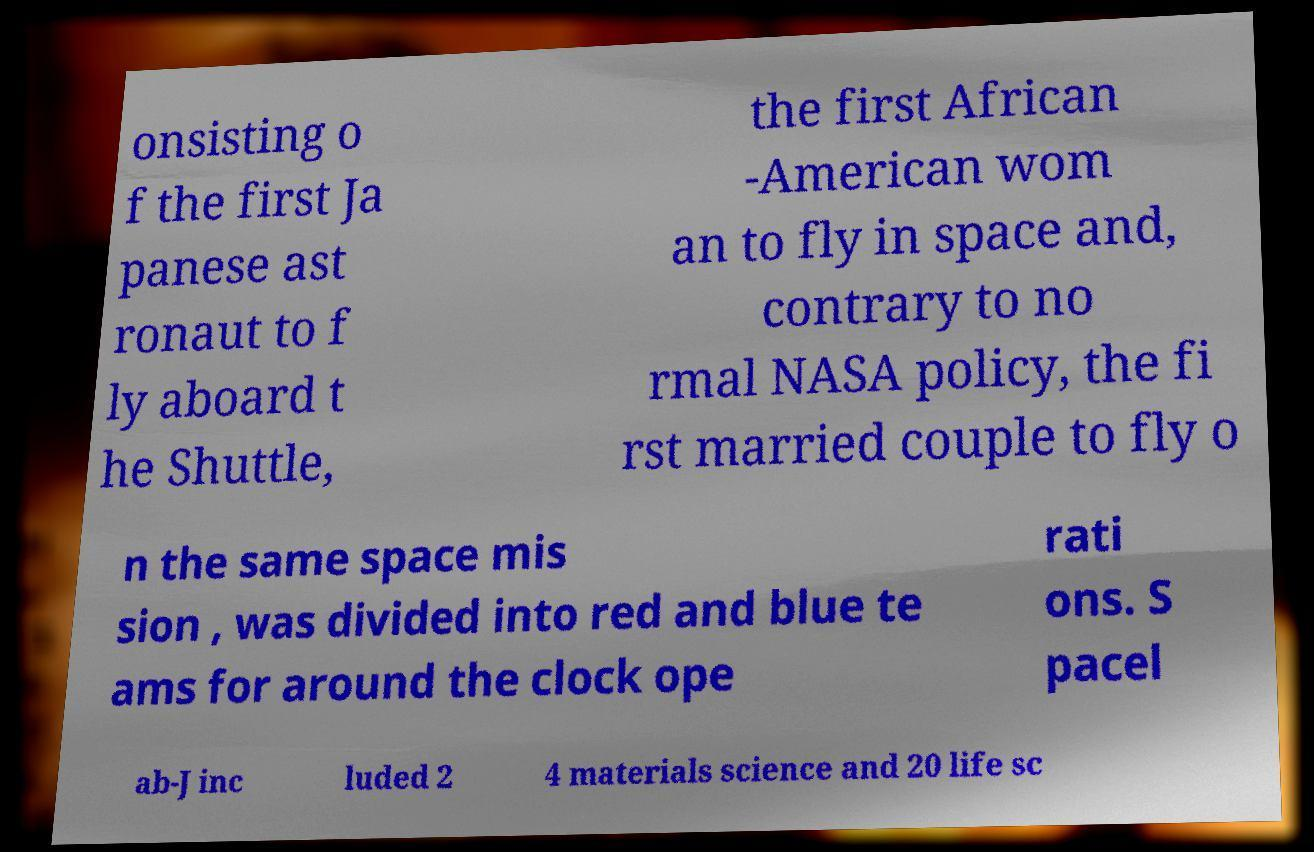There's text embedded in this image that I need extracted. Can you transcribe it verbatim? onsisting o f the first Ja panese ast ronaut to f ly aboard t he Shuttle, the first African -American wom an to fly in space and, contrary to no rmal NASA policy, the fi rst married couple to fly o n the same space mis sion , was divided into red and blue te ams for around the clock ope rati ons. S pacel ab-J inc luded 2 4 materials science and 20 life sc 